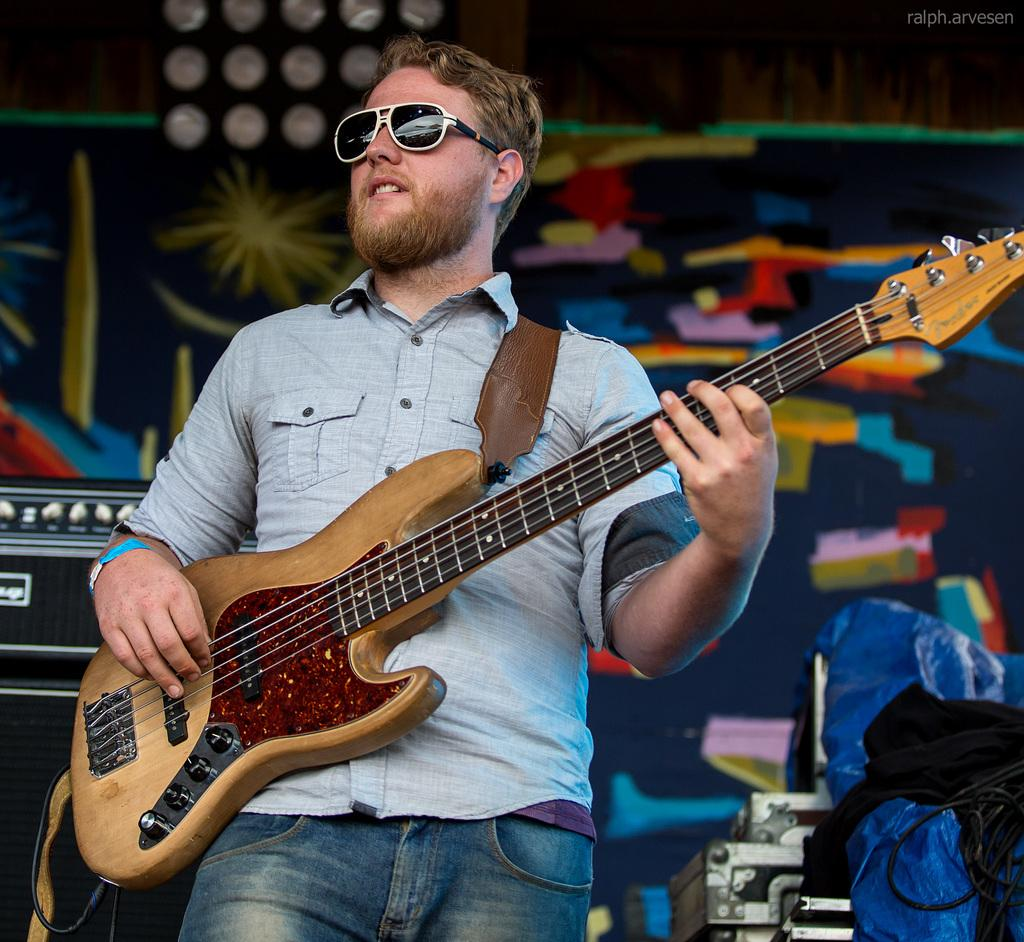Who is present in the image? There is a man in the image. What is the man holding in the image? The man is holding a guitar. What accessory is the man wearing in the image? The man is wearing shades. Can you describe the background of the image? There is a designed wall with lights in the background of the image. What type of potato dish can be seen on the table in the image? There is no potato dish present in the image; it features a man holding a guitar and wearing shades in front of a designed wall with lights. 